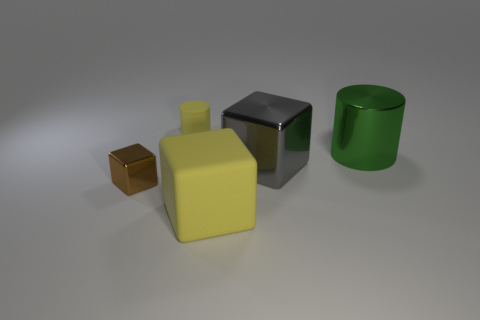Subtract all metal cubes. How many cubes are left? 1 Add 5 tiny blocks. How many objects exist? 10 Subtract all green cylinders. How many cylinders are left? 1 Subtract all blocks. How many objects are left? 2 Subtract 1 blocks. How many blocks are left? 2 Subtract all yellow cylinders. Subtract all cyan cubes. How many cylinders are left? 1 Subtract all tiny green cubes. Subtract all big blocks. How many objects are left? 3 Add 5 yellow rubber cylinders. How many yellow rubber cylinders are left? 6 Add 1 tiny shiny objects. How many tiny shiny objects exist? 2 Subtract 0 brown cylinders. How many objects are left? 5 